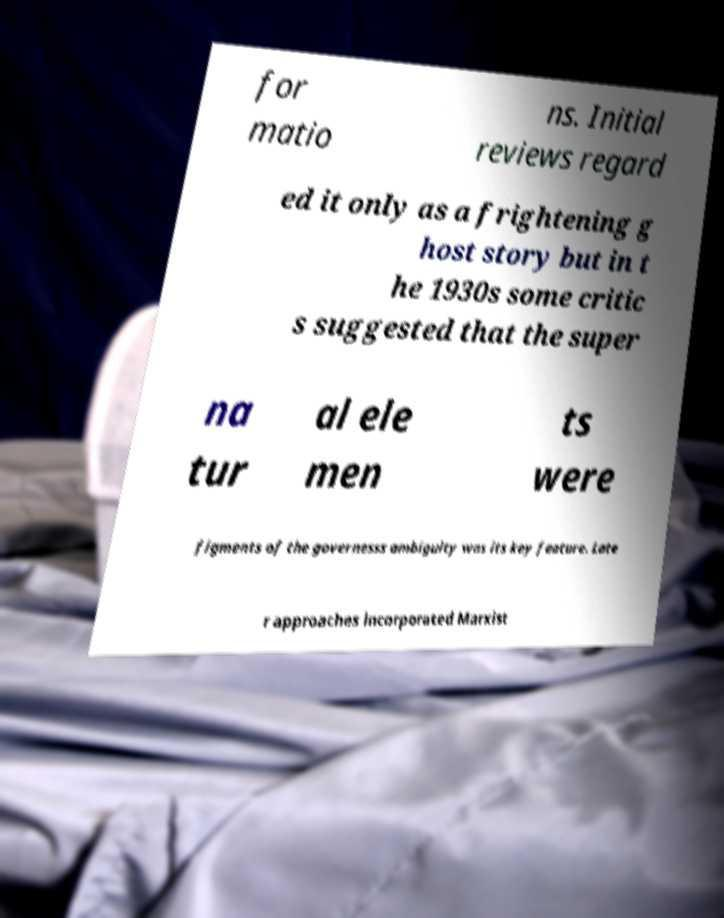Could you extract and type out the text from this image? for matio ns. Initial reviews regard ed it only as a frightening g host story but in t he 1930s some critic s suggested that the super na tur al ele men ts were figments of the governesss ambiguity was its key feature. Late r approaches incorporated Marxist 